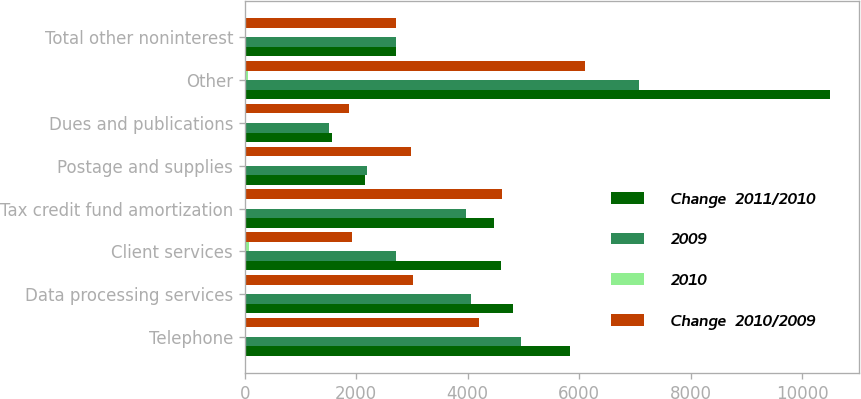Convert chart to OTSL. <chart><loc_0><loc_0><loc_500><loc_500><stacked_bar_chart><ecel><fcel>Telephone<fcel>Data processing services<fcel>Client services<fcel>Tax credit fund amortization<fcel>Postage and supplies<fcel>Dues and publications<fcel>Other<fcel>Total other noninterest<nl><fcel>Change  2011/2010<fcel>5835<fcel>4811<fcel>4594<fcel>4474<fcel>2162<fcel>1570<fcel>10499<fcel>2716<nl><fcel>2009<fcel>4952<fcel>4060<fcel>2716<fcel>3965<fcel>2198<fcel>1519<fcel>7081<fcel>2716<nl><fcel>2010<fcel>17.8<fcel>18.5<fcel>69.1<fcel>12.8<fcel>1.6<fcel>3.4<fcel>48.3<fcel>16.3<nl><fcel>Change  2010/2009<fcel>4202<fcel>3025<fcel>1923<fcel>4614<fcel>2985<fcel>1872<fcel>6102<fcel>2716<nl></chart> 